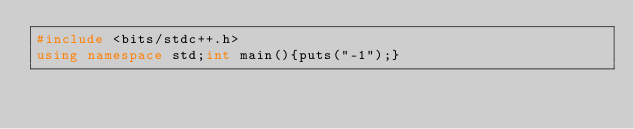<code> <loc_0><loc_0><loc_500><loc_500><_C++_>#include <bits/stdc++.h>
using namespace std;int main(){puts("-1");}</code> 